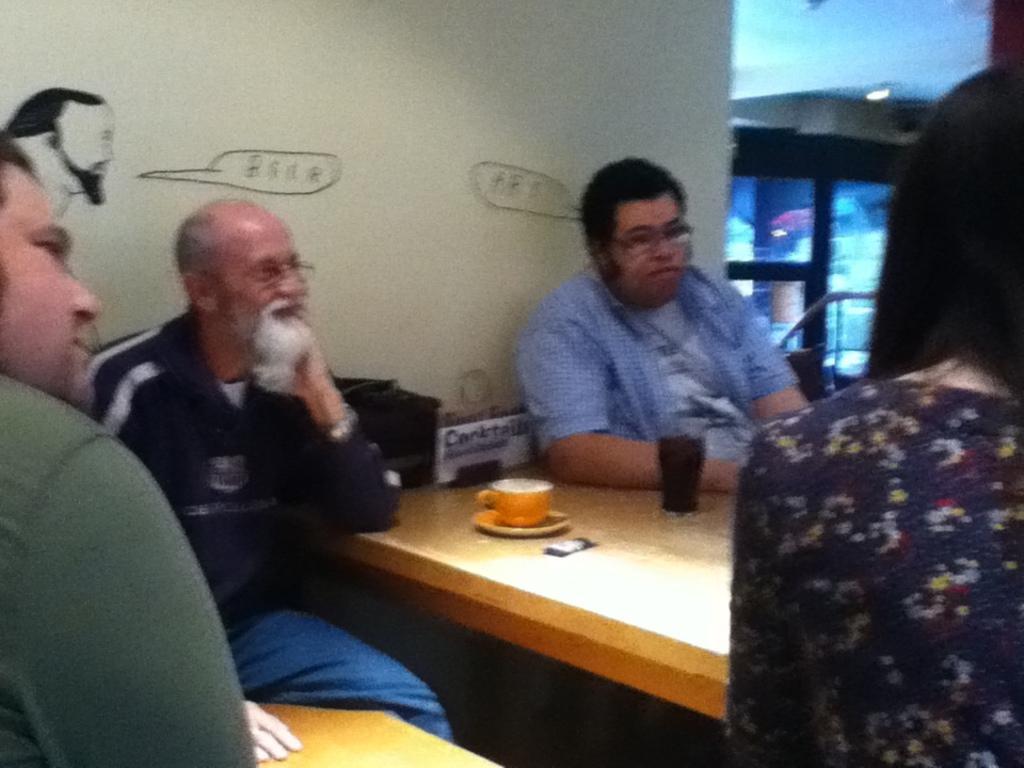Describe this image in one or two sentences. In this picture we can see four persons sitting on chair and in front of them there is table and on table we have glass, cup, saucer and in background we can see wall with painting, fence, window, light. 